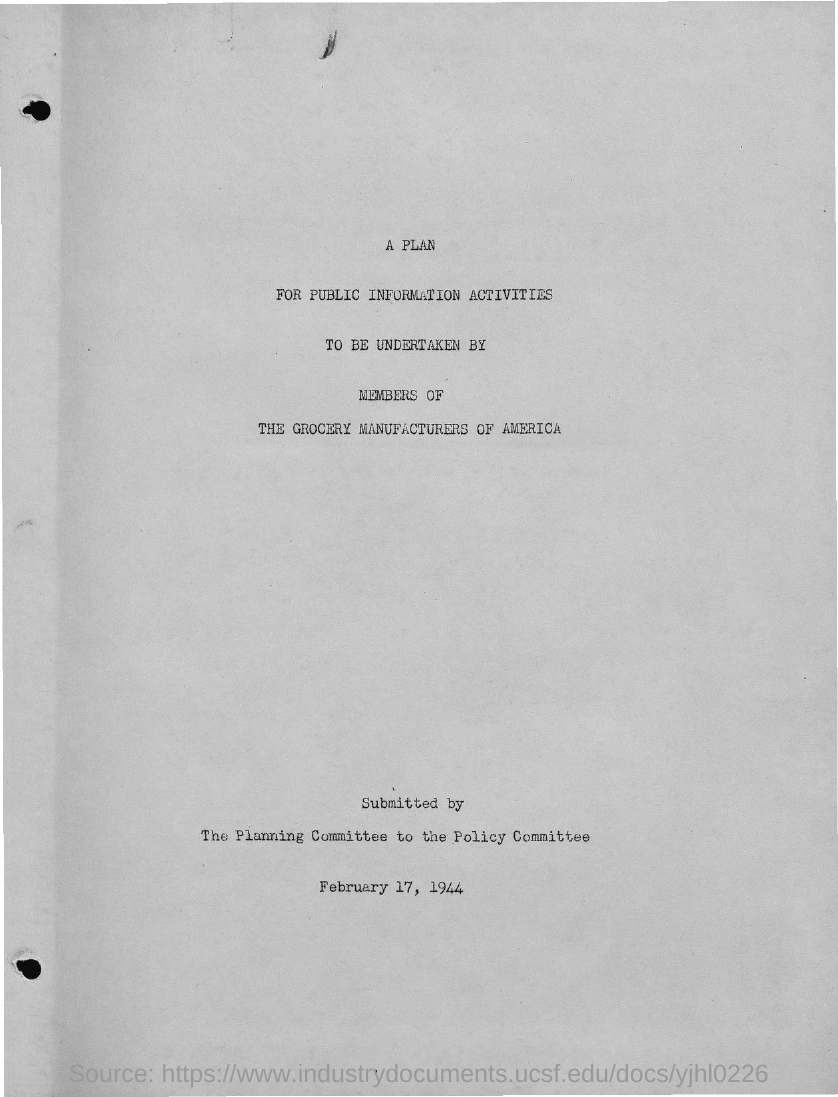What is the title?
Your response must be concise. A plan for public information activities. Who will be undertaking the plan?
Provide a short and direct response. Members of the grocery manufacturers of america. By whom is the plan submitted?
Ensure brevity in your answer.  The planning committee. On which date  was  it submitted?
Your answer should be very brief. February 17, 1944. 